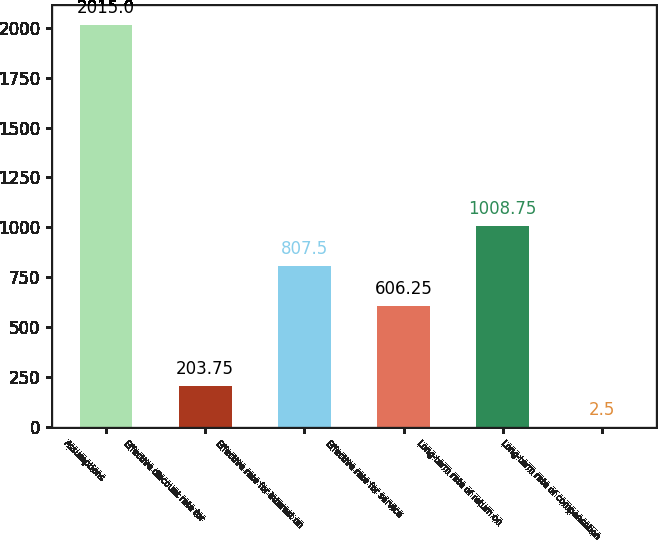Convert chart. <chart><loc_0><loc_0><loc_500><loc_500><bar_chart><fcel>Assumptions<fcel>Effective discount rate for<fcel>Effective rate for interest on<fcel>Effective rate for service<fcel>Long-term rate of return on<fcel>Long-term rate of compensation<nl><fcel>2015<fcel>203.75<fcel>807.5<fcel>606.25<fcel>1008.75<fcel>2.5<nl></chart> 